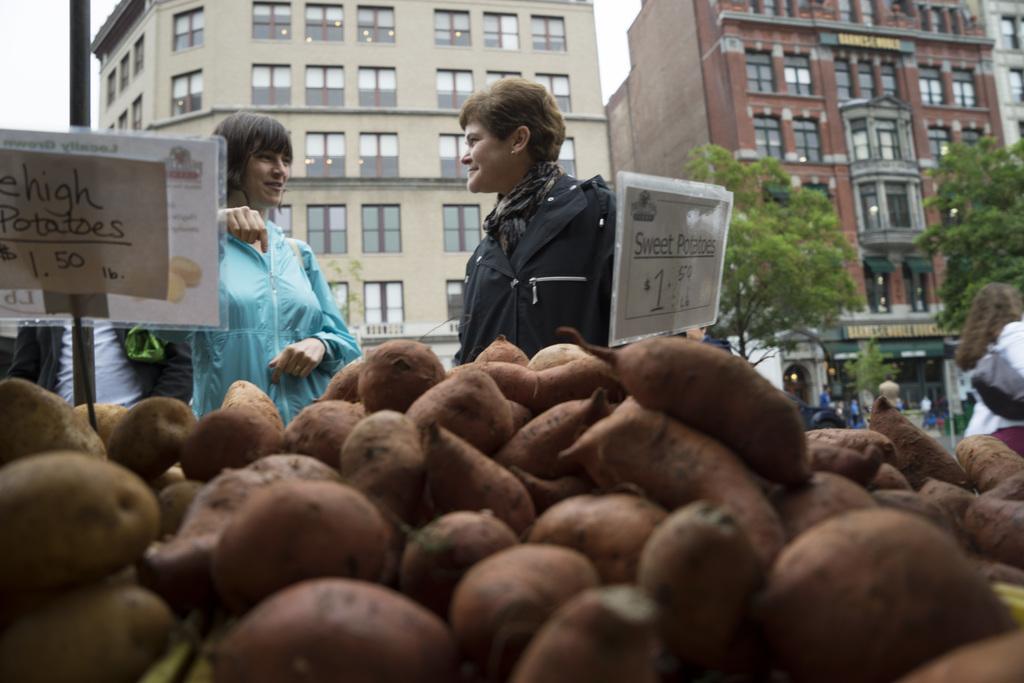In one or two sentences, can you explain what this image depicts? In the foreground of the image I can see sweet potatoes and I can see price boards are placed here. On the left side of the image I can see a person wearing blue color dress and another person wearing black color dress are standing. The background of the image is blurred, where we can see a few more people are walking on the road, we can see trees, buildings and the sky. 